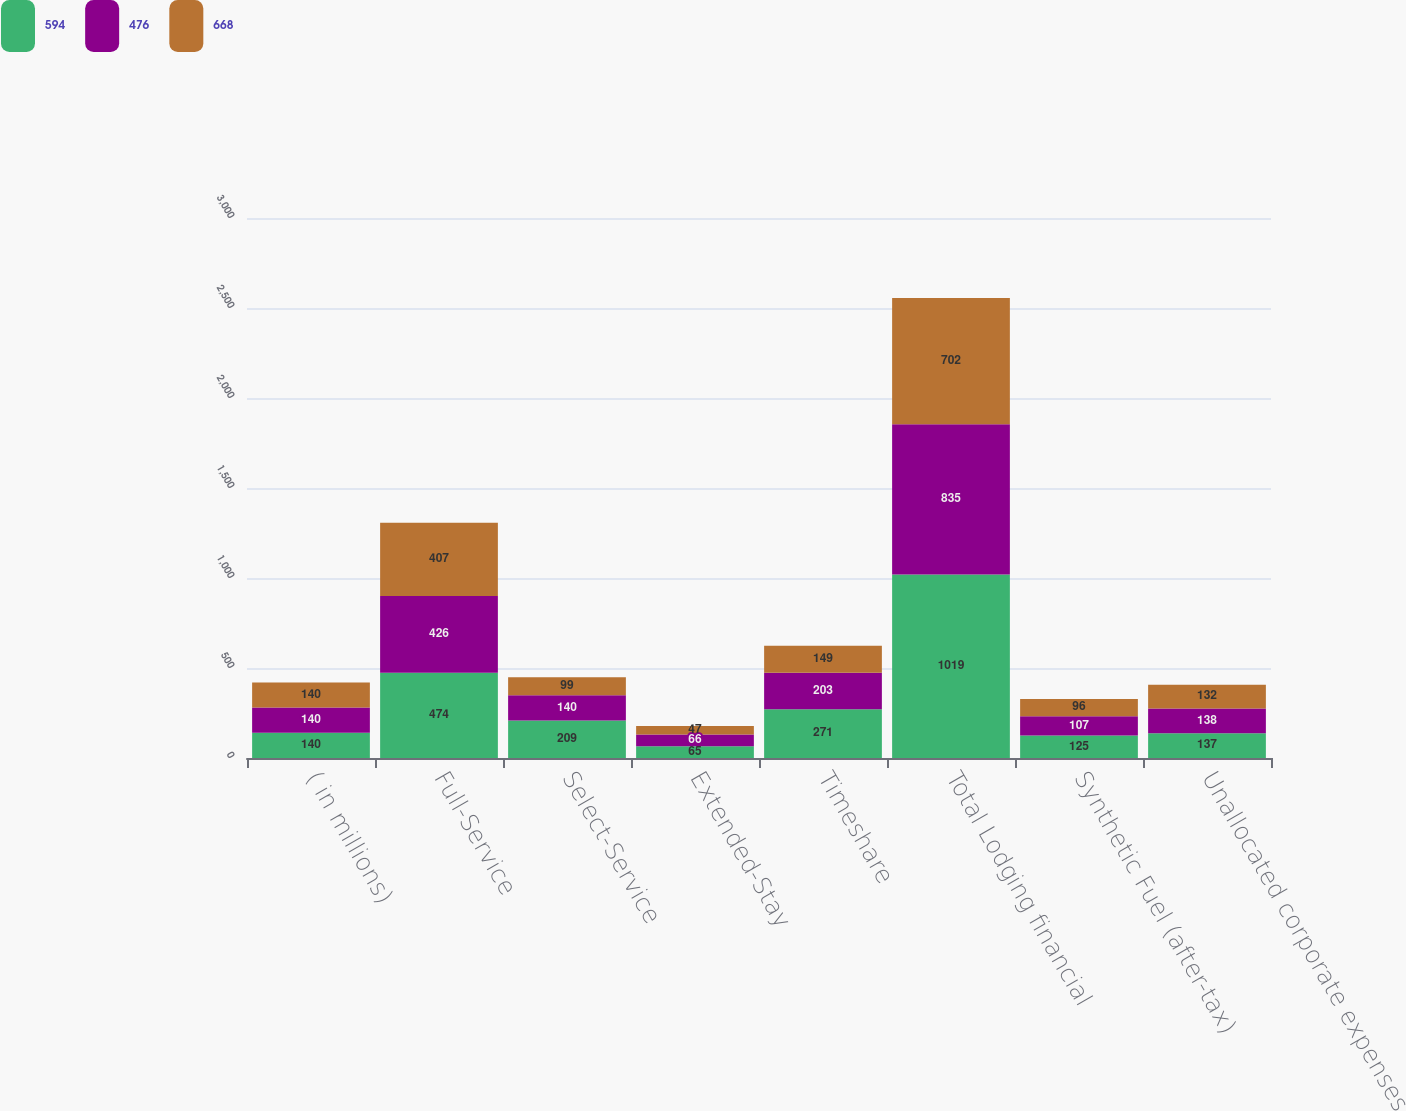<chart> <loc_0><loc_0><loc_500><loc_500><stacked_bar_chart><ecel><fcel>( in millions)<fcel>Full-Service<fcel>Select-Service<fcel>Extended-Stay<fcel>Timeshare<fcel>Total Lodging financial<fcel>Synthetic Fuel (after-tax)<fcel>Unallocated corporate expenses<nl><fcel>594<fcel>140<fcel>474<fcel>209<fcel>65<fcel>271<fcel>1019<fcel>125<fcel>137<nl><fcel>476<fcel>140<fcel>426<fcel>140<fcel>66<fcel>203<fcel>835<fcel>107<fcel>138<nl><fcel>668<fcel>140<fcel>407<fcel>99<fcel>47<fcel>149<fcel>702<fcel>96<fcel>132<nl></chart> 